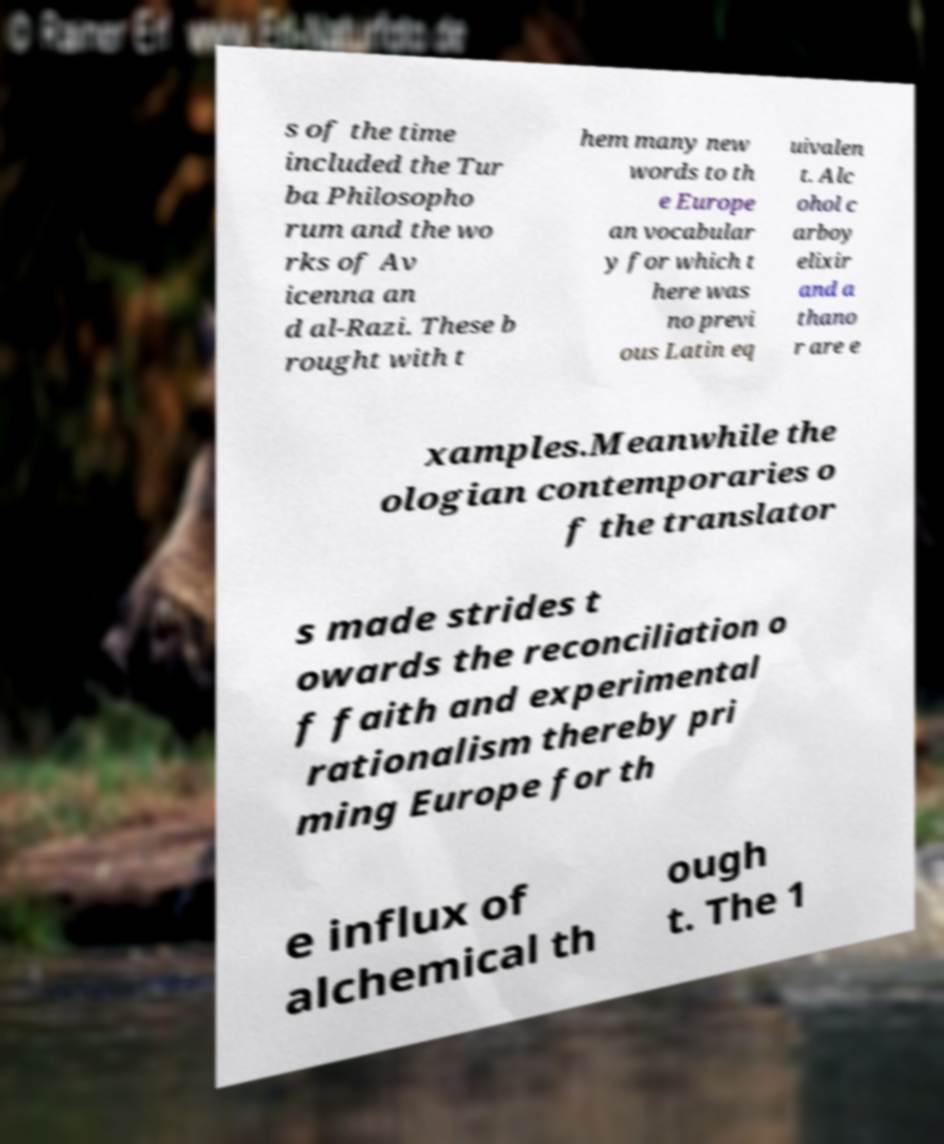Can you read and provide the text displayed in the image?This photo seems to have some interesting text. Can you extract and type it out for me? s of the time included the Tur ba Philosopho rum and the wo rks of Av icenna an d al-Razi. These b rought with t hem many new words to th e Europe an vocabular y for which t here was no previ ous Latin eq uivalen t. Alc ohol c arboy elixir and a thano r are e xamples.Meanwhile the ologian contemporaries o f the translator s made strides t owards the reconciliation o f faith and experimental rationalism thereby pri ming Europe for th e influx of alchemical th ough t. The 1 